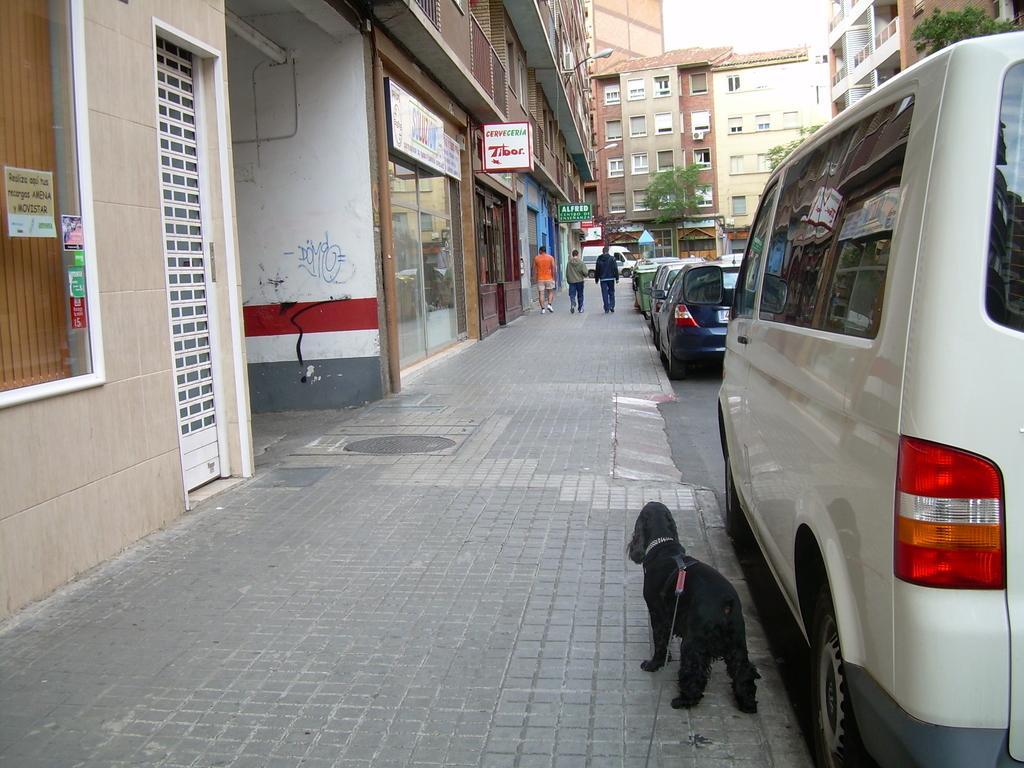Please provide a concise description of this image. In this image, we can see some buildings and trees. There are three persons in the middle of the image walking on the footpath. There are cars on the road. There is a dog at the bottom of the image. 